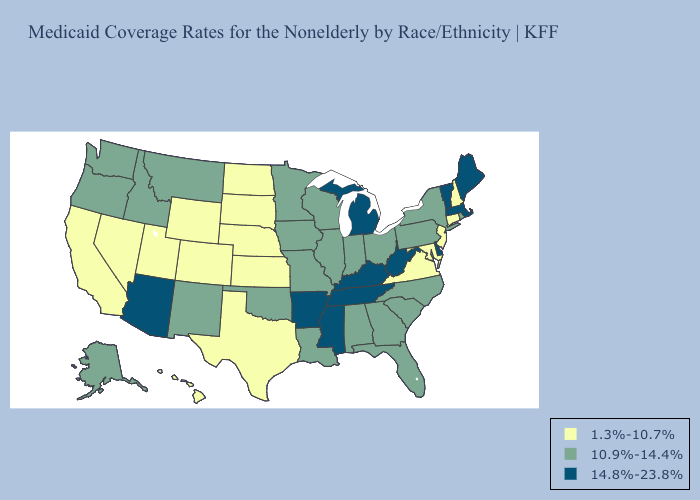What is the value of Utah?
Short answer required. 1.3%-10.7%. Does Alabama have a lower value than Arkansas?
Quick response, please. Yes. Does Kentucky have the lowest value in the South?
Keep it brief. No. What is the value of Idaho?
Concise answer only. 10.9%-14.4%. What is the lowest value in the USA?
Concise answer only. 1.3%-10.7%. Does Maryland have the lowest value in the USA?
Give a very brief answer. Yes. What is the highest value in the Northeast ?
Short answer required. 14.8%-23.8%. Does South Dakota have the lowest value in the MidWest?
Give a very brief answer. Yes. Which states hav the highest value in the South?
Quick response, please. Arkansas, Delaware, Kentucky, Mississippi, Tennessee, West Virginia. Name the states that have a value in the range 1.3%-10.7%?
Concise answer only. California, Colorado, Connecticut, Hawaii, Kansas, Maryland, Nebraska, Nevada, New Hampshire, New Jersey, North Dakota, South Dakota, Texas, Utah, Virginia, Wyoming. Among the states that border Ohio , which have the highest value?
Write a very short answer. Kentucky, Michigan, West Virginia. Among the states that border Wisconsin , which have the highest value?
Write a very short answer. Michigan. What is the lowest value in the MidWest?
Keep it brief. 1.3%-10.7%. What is the value of Missouri?
Give a very brief answer. 10.9%-14.4%. What is the lowest value in the MidWest?
Give a very brief answer. 1.3%-10.7%. 